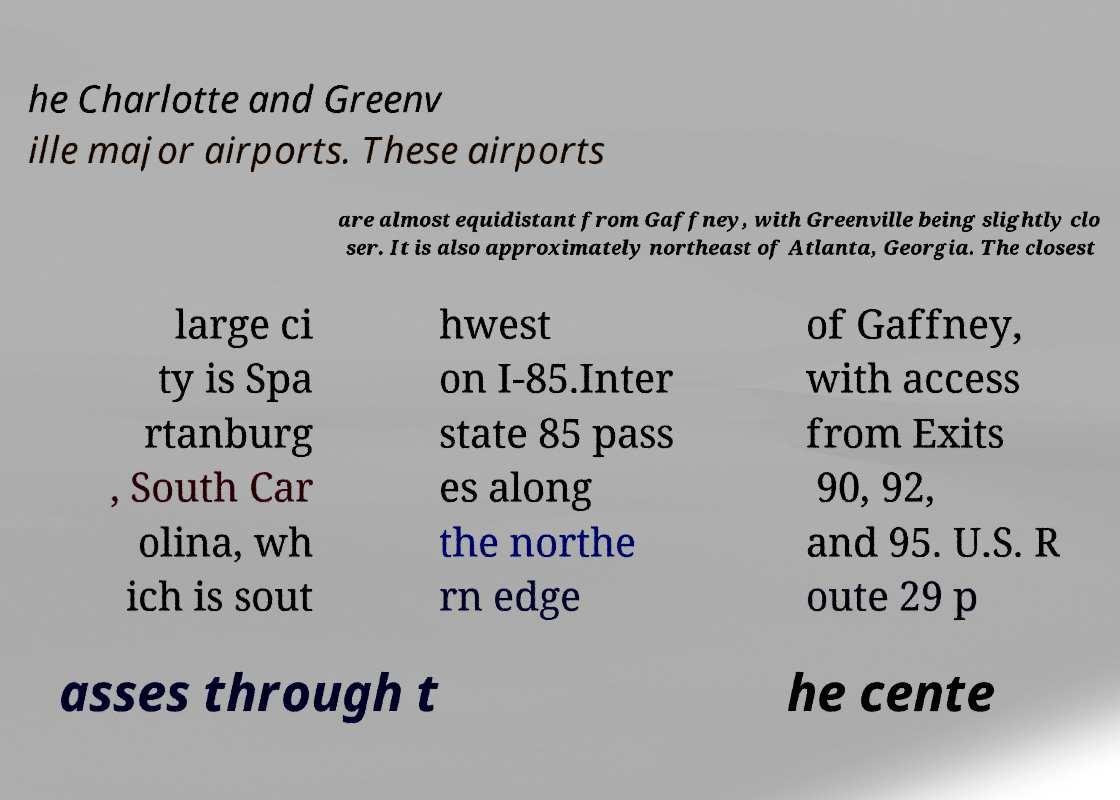Can you read and provide the text displayed in the image?This photo seems to have some interesting text. Can you extract and type it out for me? he Charlotte and Greenv ille major airports. These airports are almost equidistant from Gaffney, with Greenville being slightly clo ser. It is also approximately northeast of Atlanta, Georgia. The closest large ci ty is Spa rtanburg , South Car olina, wh ich is sout hwest on I-85.Inter state 85 pass es along the northe rn edge of Gaffney, with access from Exits 90, 92, and 95. U.S. R oute 29 p asses through t he cente 